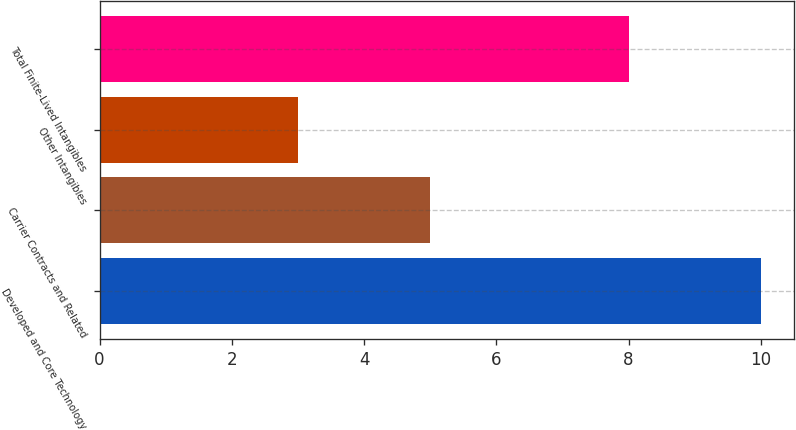<chart> <loc_0><loc_0><loc_500><loc_500><bar_chart><fcel>Developed and Core Technology<fcel>Carrier Contracts and Related<fcel>Other Intangibles<fcel>Total Finite-Lived Intangibles<nl><fcel>10<fcel>5<fcel>3<fcel>8<nl></chart> 